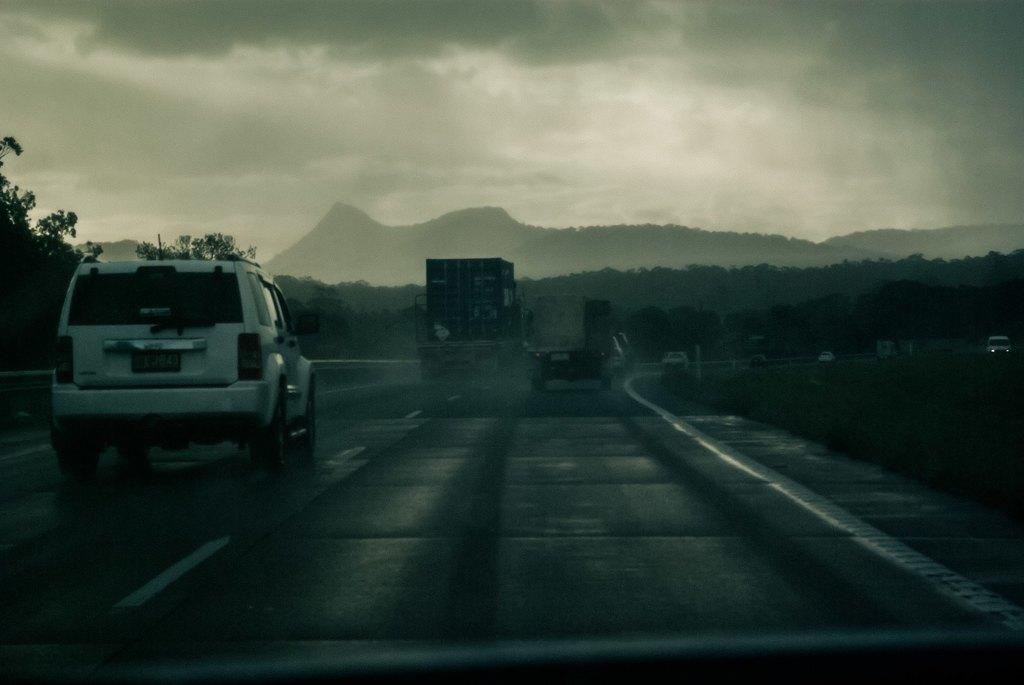What is the main feature of the image? There is a road in the image. What is happening on the road? There are vehicles on the road. What can be seen in the background of the image? There are trees and clouds visible in the image. What part of the natural environment is visible in the image? The sky is visible in the image. Can you see any clovers growing on the side of the road in the image? There are no clovers visible in the image. What type of feather can be seen attached to the wing of the bird in the image? There are no birds or feathers present in the image. 